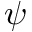<formula> <loc_0><loc_0><loc_500><loc_500>\psi</formula> 